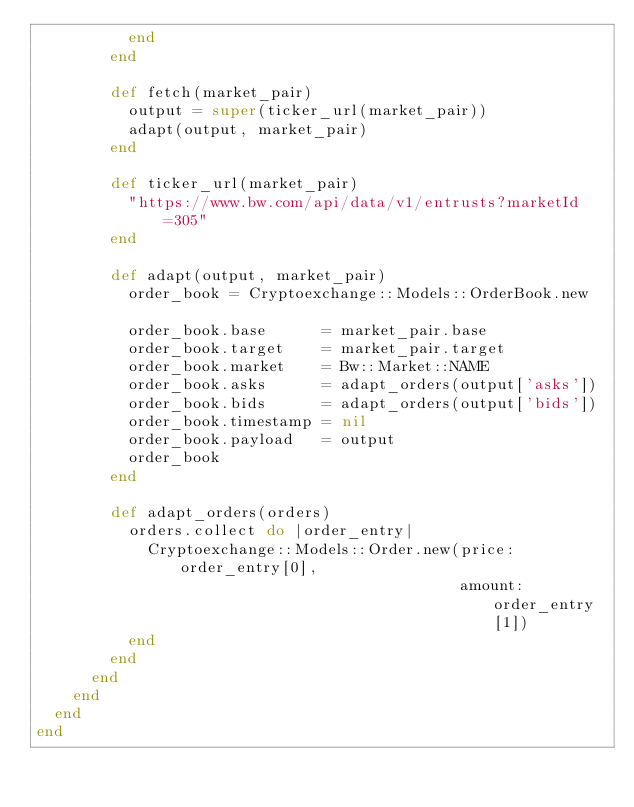<code> <loc_0><loc_0><loc_500><loc_500><_Ruby_>          end
        end

        def fetch(market_pair)
          output = super(ticker_url(market_pair))
          adapt(output, market_pair)
        end

        def ticker_url(market_pair)
          "https://www.bw.com/api/data/v1/entrusts?marketId=305"
        end

        def adapt(output, market_pair)
          order_book = Cryptoexchange::Models::OrderBook.new

          order_book.base      = market_pair.base
          order_book.target    = market_pair.target
          order_book.market    = Bw::Market::NAME
          order_book.asks      = adapt_orders(output['asks'])
          order_book.bids      = adapt_orders(output['bids'])
          order_book.timestamp = nil
          order_book.payload   = output
          order_book
        end

        def adapt_orders(orders)
          orders.collect do |order_entry|
            Cryptoexchange::Models::Order.new(price: order_entry[0],
                                              amount: order_entry[1])
          end
        end
      end
    end
  end
end
</code> 